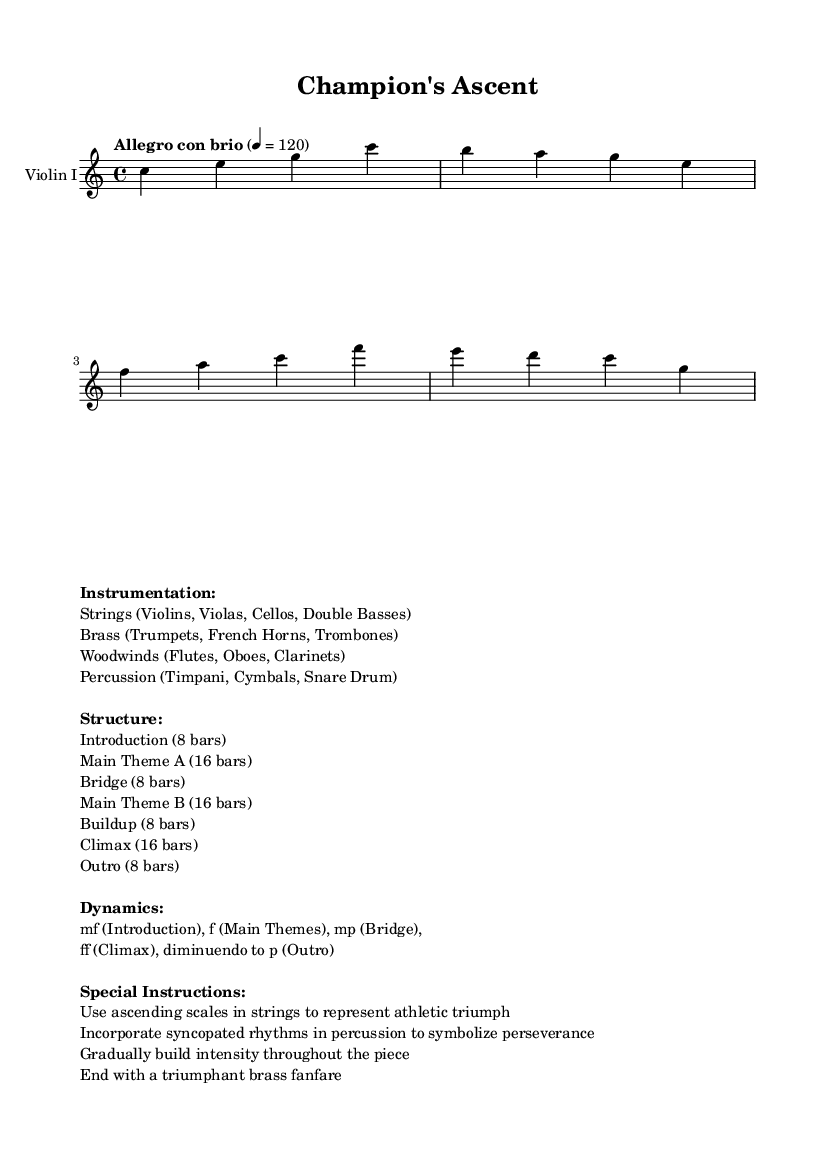What is the key signature of this music? The key signature is C major, which has no sharps or flats.
Answer: C major What is the time signature of the composition? The time signature is indicated at the beginning of the music as 4/4, meaning there are four beats per measure.
Answer: 4/4 What is the tempo marking for this piece? The tempo marking, "Allegro con brio," indicates that the piece should be played lively and with vigor, typically at a speed of 120 beats per minute.
Answer: Allegro con brio What is the structure of the composition? The composition includes several sections: Introduction, Main Theme A, Bridge, Main Theme B, Buildup, Climax, and Outro, as outlined in the markup information.
Answer: Introduction, Main Theme A, Bridge, Main Theme B, Buildup, Climax, Outro What dynamic level is used in the climax? The climax section reaches a dynamic of "ff," meaning fortissimo, which indicates a very loud volume.
Answer: ff How many bars are in the Main Theme A? The markup specifies that Main Theme A consists of 16 bars, detailing the specific length of that section in the overall structure.
Answer: 16 bars What special instruction is given for the string instruments? One special instruction states to "Use ascending scales in strings to represent athletic triumph," which guides the string players on how to convey the piece's theme.
Answer: Use ascending scales 